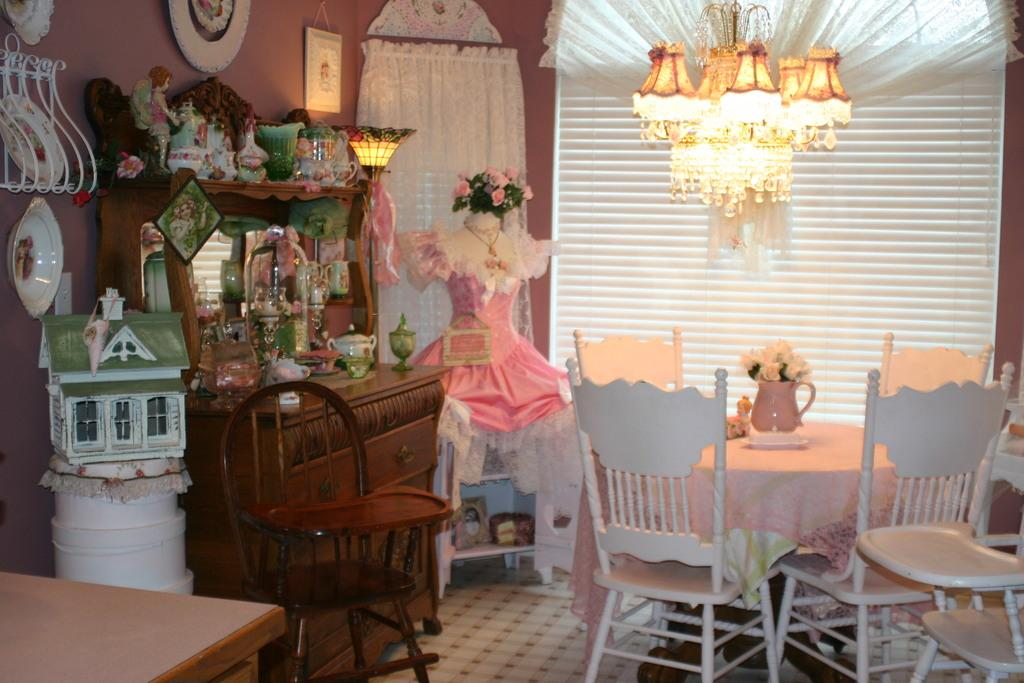What type of furniture is present in the image? There are tables and chairs in the image. What type of illumination is present in the image? There are lights in the image. What type of architectural feature is present in the image? There is a wall in the image. What type of window treatment is present in the image? There is a curtain in the image. Can you see any dinosaurs in the image? No, there are no dinosaurs present in the image. What type of tooth is visible in the image? There are no teeth visible in the image, as it features tables, chairs, lights, walls, and curtains. 